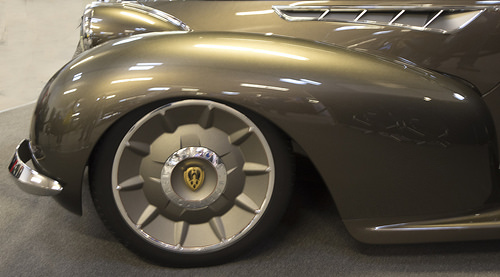<image>
Is there a car behind the wheel rim? No. The car is not behind the wheel rim. From this viewpoint, the car appears to be positioned elsewhere in the scene. 